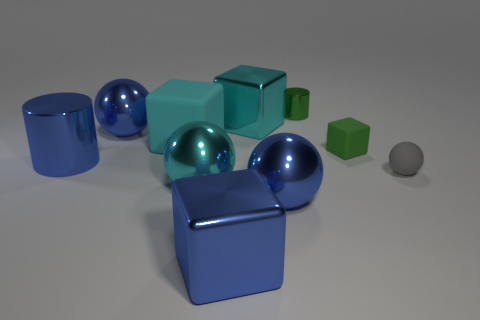There is a small matte thing that is behind the gray thing; is its color the same as the tiny shiny cylinder?
Offer a very short reply. Yes. There is a tiny green shiny object; how many blue metal blocks are behind it?
Your response must be concise. 0. Are there more cyan things than blue shiny things?
Provide a short and direct response. No. There is a shiny thing that is in front of the green rubber object and behind the large cyan ball; what is its shape?
Ensure brevity in your answer.  Cylinder. Are there any large cyan matte objects?
Keep it short and to the point. Yes. There is a blue object that is the same shape as the green matte object; what is its material?
Give a very brief answer. Metal. There is a matte object that is to the left of the cyan metallic thing that is to the left of the cyan object that is behind the large matte thing; what shape is it?
Keep it short and to the point. Cube. What is the material of the big cube that is the same color as the large metal cylinder?
Offer a very short reply. Metal. What number of large cyan metallic things are the same shape as the gray object?
Make the answer very short. 1. There is a sphere that is right of the tiny metallic thing; is it the same color as the metal ball behind the blue shiny cylinder?
Keep it short and to the point. No. 